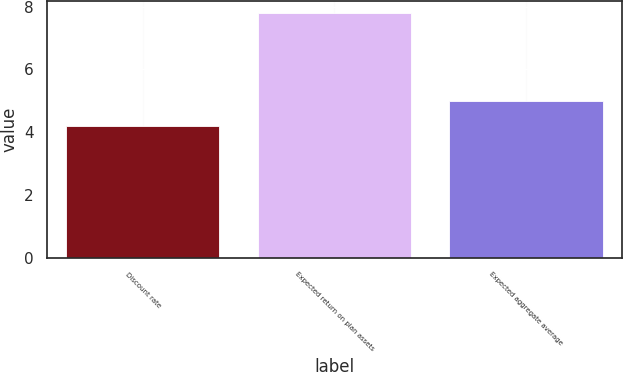<chart> <loc_0><loc_0><loc_500><loc_500><bar_chart><fcel>Discount rate<fcel>Expected return on plan assets<fcel>Expected aggregate average<nl><fcel>4.2<fcel>7.8<fcel>5<nl></chart> 